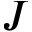Convert formula to latex. <formula><loc_0><loc_0><loc_500><loc_500>J</formula> 